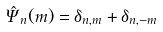<formula> <loc_0><loc_0><loc_500><loc_500>\hat { \Psi } _ { n } ( { m } ) = \delta _ { { n } , { m } } + \delta _ { { n } , { - m } }</formula> 